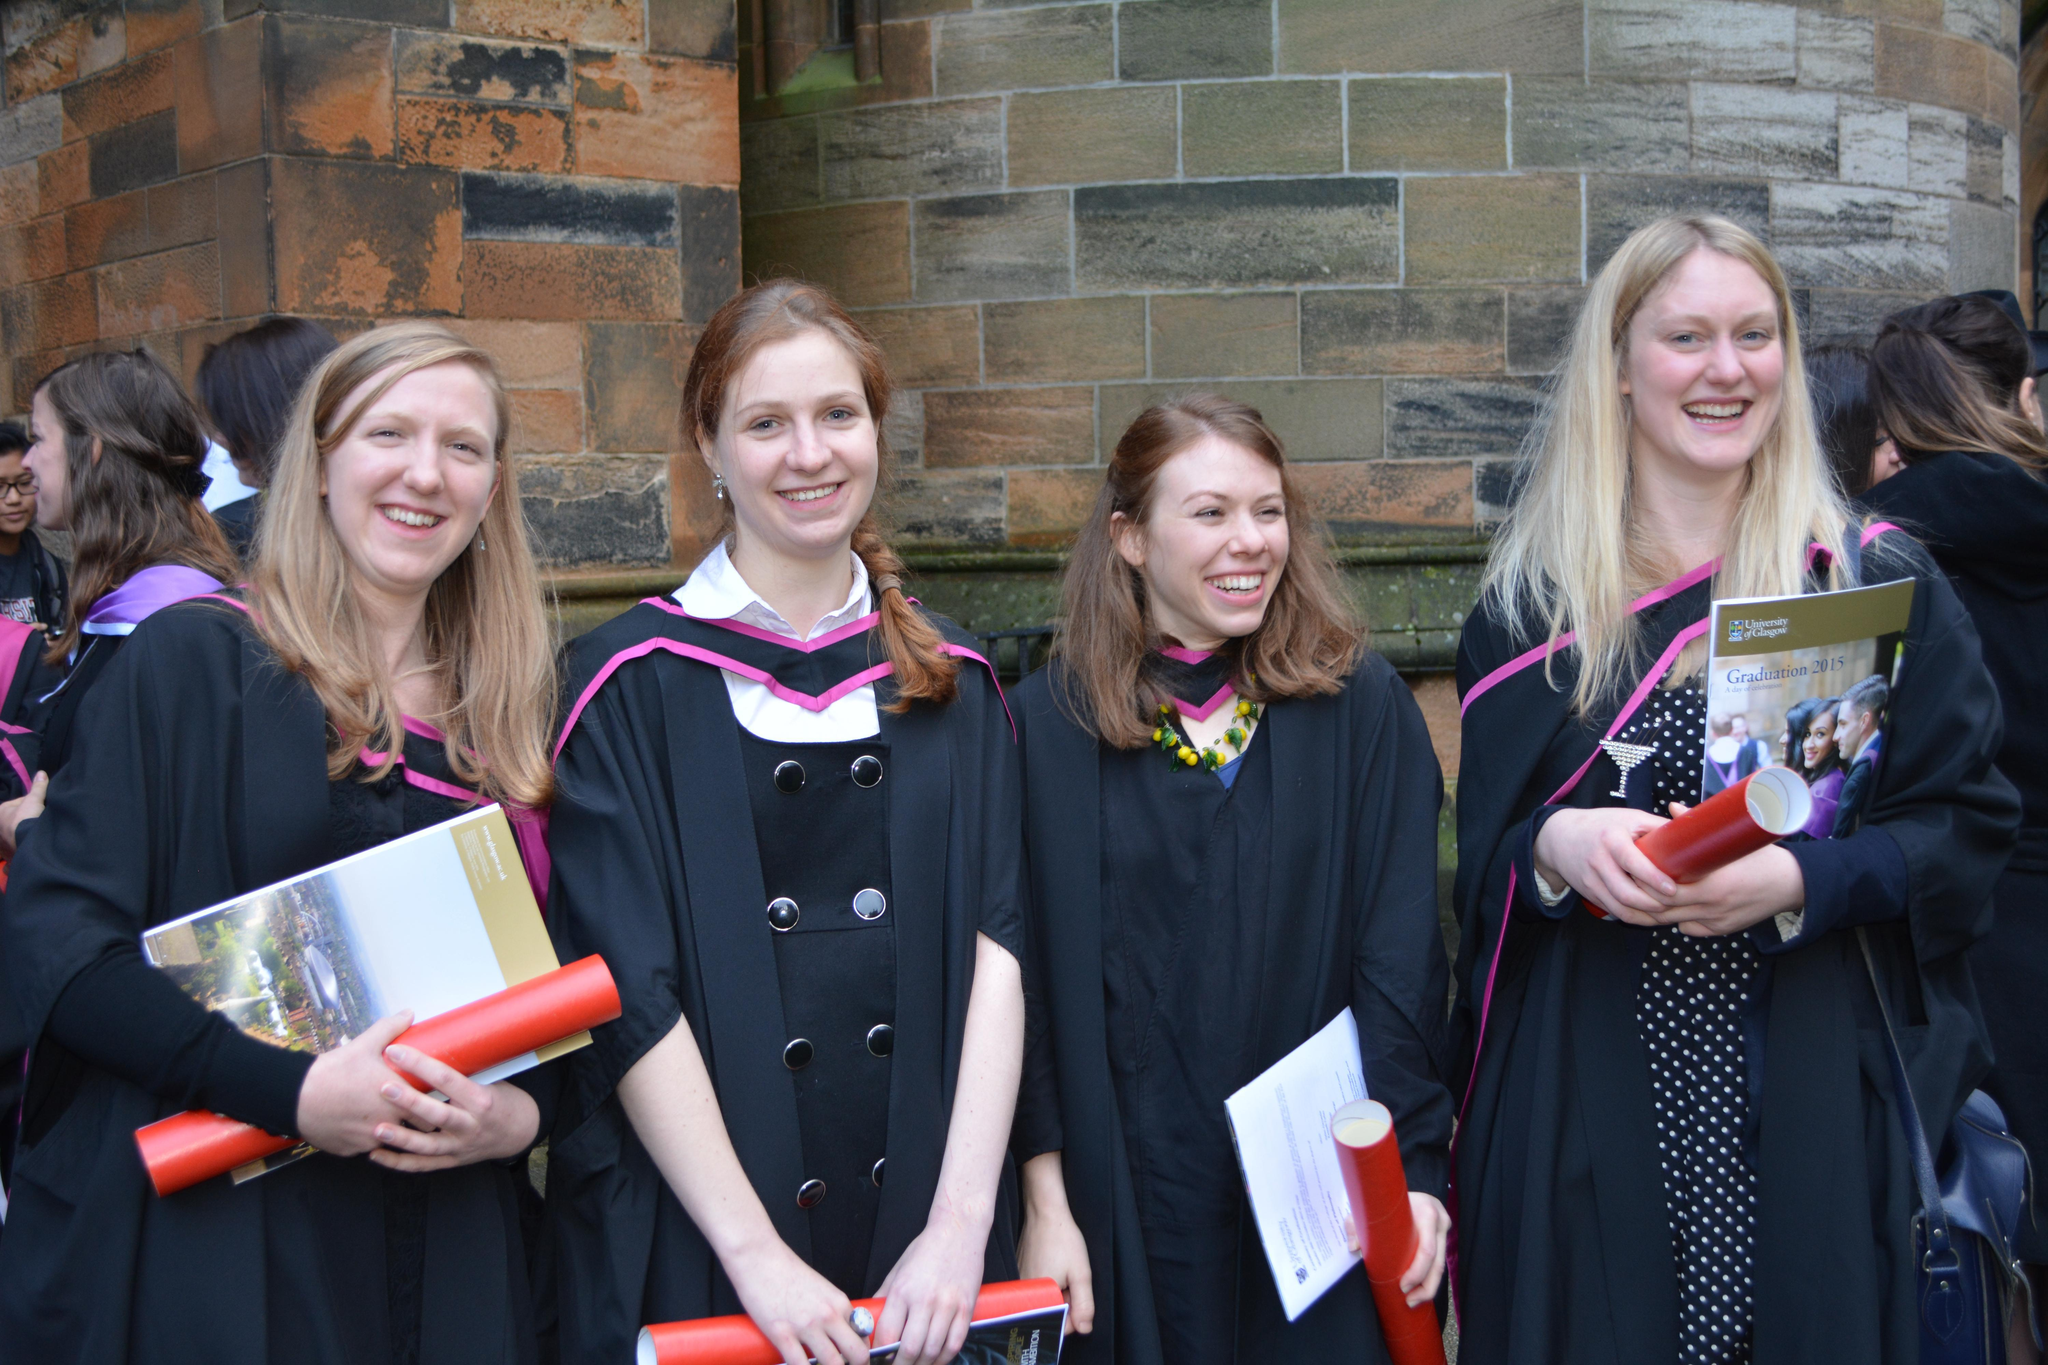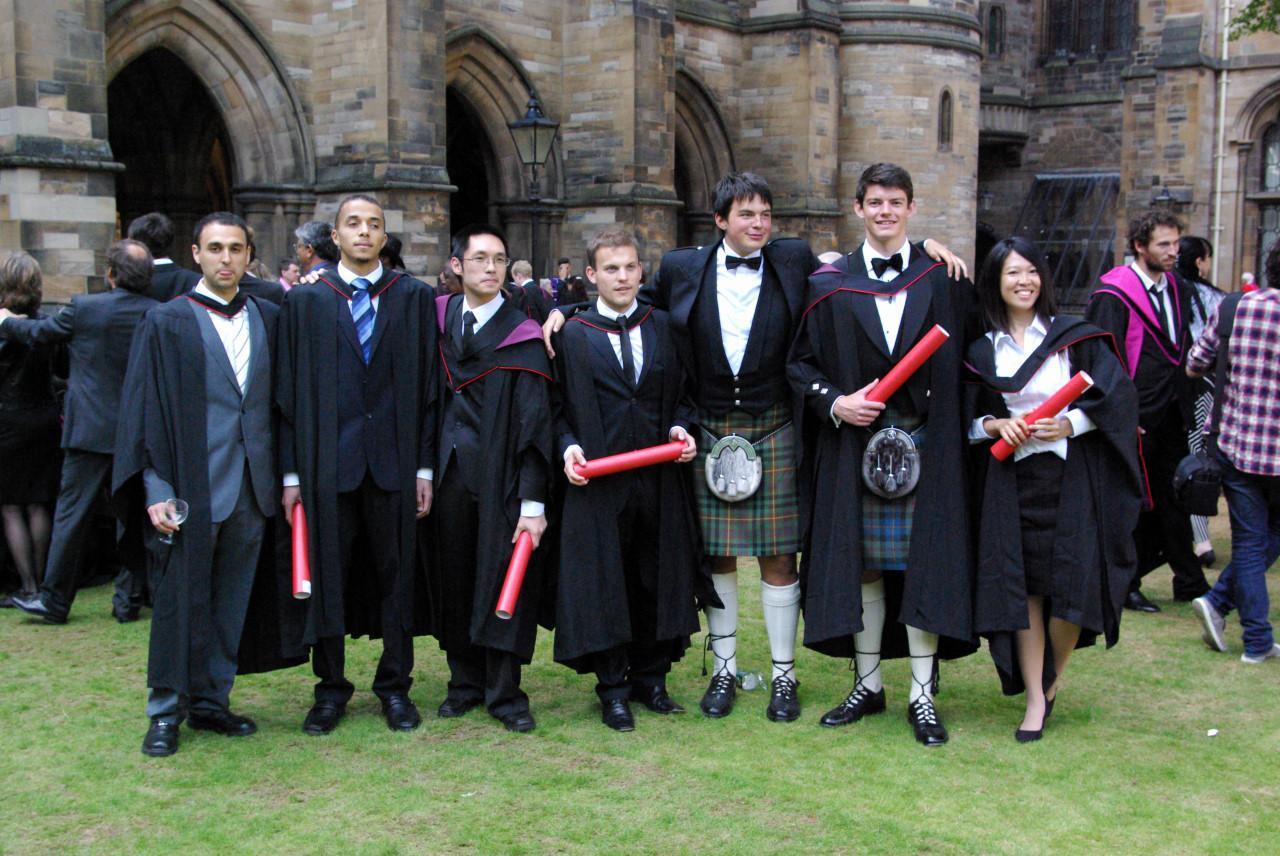The first image is the image on the left, the second image is the image on the right. Assess this claim about the two images: "In each image, at least one black-robed graduate is holding a diploma in a red tube, while standing in front of a large stone building.". Correct or not? Answer yes or no. Yes. The first image is the image on the left, the second image is the image on the right. Analyze the images presented: Is the assertion "Right image shows multiple graduates holding red rolled items, and includes a fellow in a kilt." valid? Answer yes or no. Yes. 